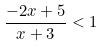<formula> <loc_0><loc_0><loc_500><loc_500>\frac { - 2 x + 5 } { x + 3 } < 1</formula> 